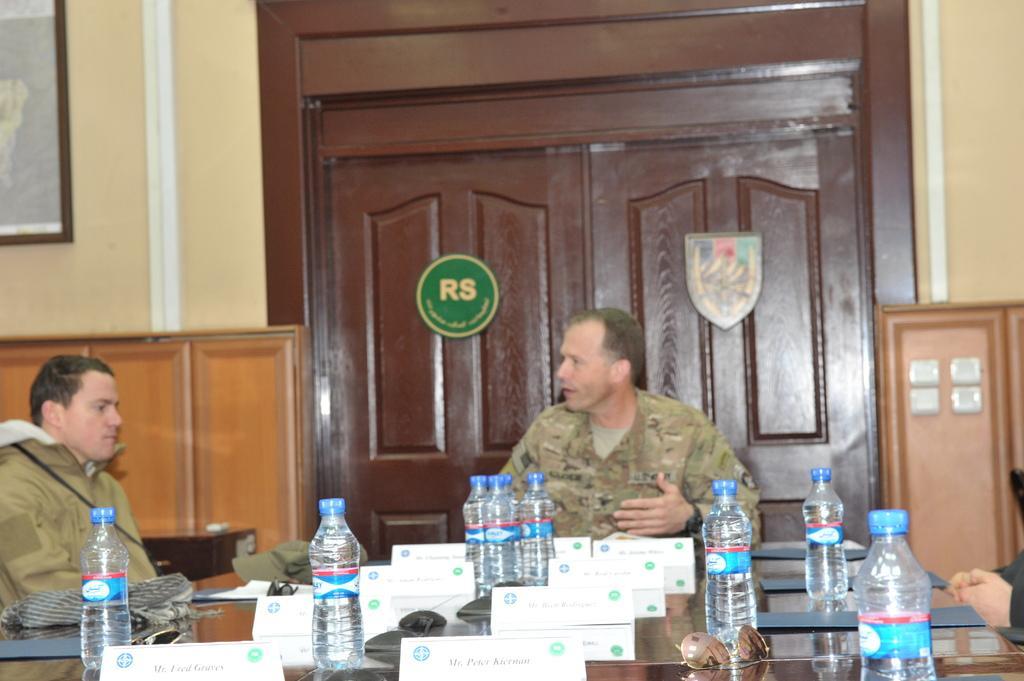Can you describe this image briefly? In this image i can see two man sitting there are few bottles, board on a table at the back ground i can see a door, a wall and a cup board a frame attached to a wall. 